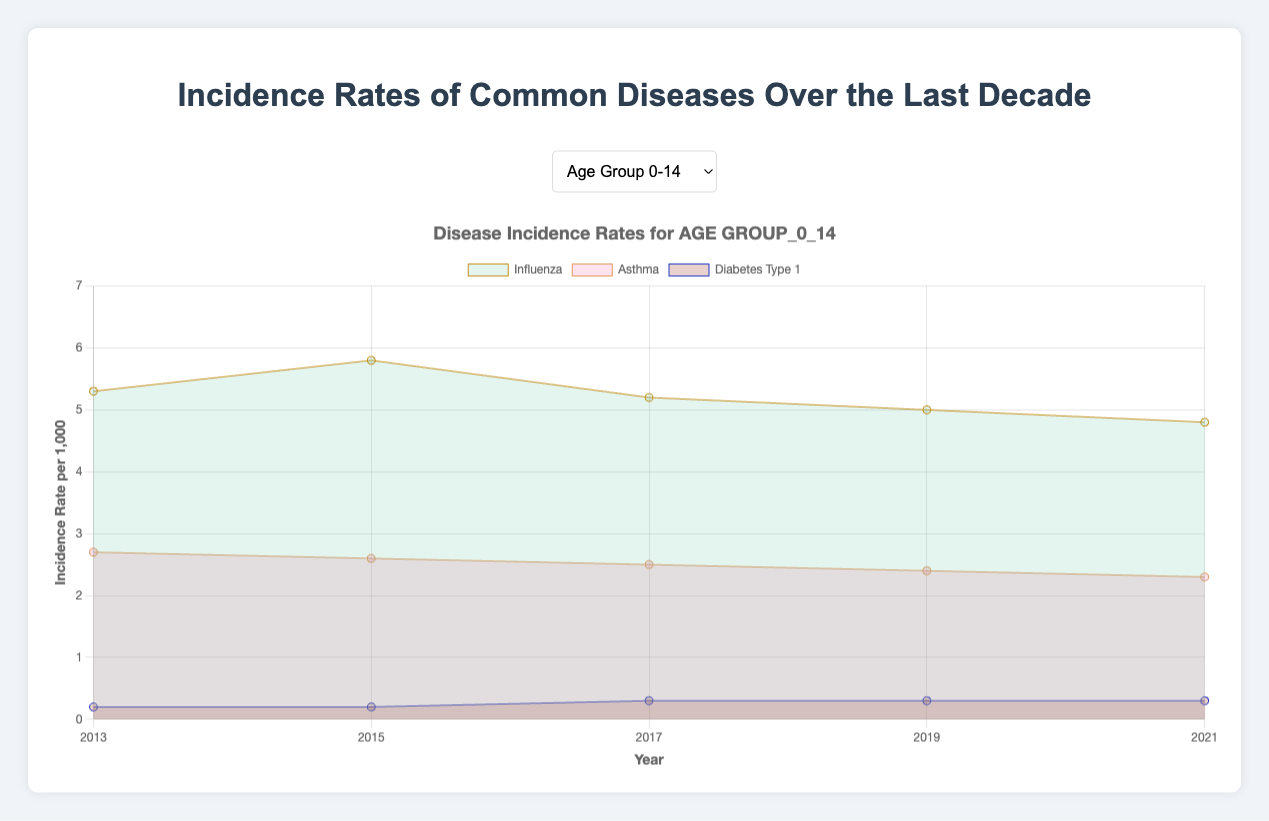What is the highest incidence rate of Influenza in the age group 0-14 over the last decade? In the line chart, looking at the data points for Influenza in the age group 0-14, we observe that the highest incidence rate is 5.8 in the year 2015.
Answer: 5.8 Which age group had the highest incidence rate of Asthma in 2013? By comparing the incidence rates of Asthma for all age groups in 2013, we find that the age group 15-29 had the highest rate at 3.2.
Answer: Age group 15-29 What was the trend in the incidence rate of Diabetes Type 2 in the age group 60+ from 2013 to 2021? Observing the incidence rates of Diabetes Type 2 for the age group 60+ over the years, we see it increases from 3.7 in 2013 to 3.9 in 2015, stays at 3.8 in 2017, and then decreases to 3.5 in 2019 and further to 3.3 in 2021. This shows a general increasing trend initially, followed by a decrease.
Answer: Increase initially, then decrease Which year had the lowest overall incidence rate of Influenza across all age groups? To determine the lowest overall incidence rate of Influenza, we compare data from all years: in 2021, the incidence rates are 4.8, 3.6, 3.5, 3.9, and 5.2 for the respective age groups. 2021 has the lowest rates compared to other years.
Answer: 2021 What is the average incidence rate of Asthma in the age group 30-44 over the entire period? The incidence rates of Asthma in the age group 30-44 are 2.3 (2013), 2.4 (2015), 2.2 (2017), 2.1 (2019), and 2.0 (2021). Summing these values gives 11, and dividing by 5 (the number of data points) provides an average of 2.2.
Answer: 2.2 Between 2013 and 2021, did the incidence rate of Diabetes Type 1 increase or decrease in the age group 15-29? Looking at the incidence rates of Diabetes Type 1 in the age group 15-29, we see they increase from 0.7 (2013) to 1.1 (2021), showing an overall increasing trend.
Answer: Increase For the age group 45-59, in which year was the difference in the incidence rates of Influenza and Asthma the greatest? By calculating the differences between Influenza and Asthma rates for each year in the age group 45-59: 4.5-1.9=2.6 (2013), 4.6-1.8=2.8 (2015), 4.3-1.7=2.6 (2017), 4.1-1.6=2.5 (2019), and 3.9-1.5=2.4 (2021). The greatest difference of 2.8 occurs in 2015.
Answer: 2015 How does the trend in the incidence rate of Diabetes Type 2 in the age group 30-44 compare to the age group 60+ over the decade? For the age group 30-44: incidence rates are 1.5 (2013), 1.6 (2015), 1.4 (2017), 1.3 (2019), and 1.2 (2021). For the age group 60+: incidence rates are 3.7 (2013), 3.9 (2015), 3.8 (2017), 3.5 (2019), and 3.3 (2021). Both groups show an initial increase followed by a decrease, but the age group 60+ has consistently higher rates.
Answer: Increase then decrease, higher in age 60+ 